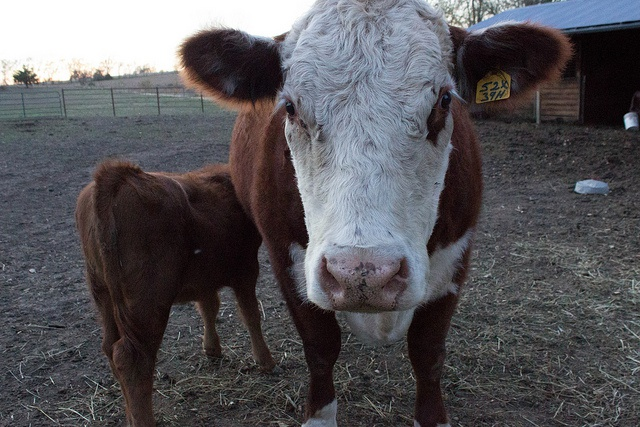Describe the objects in this image and their specific colors. I can see cow in white, black, darkgray, and gray tones and cow in white, black, gray, and maroon tones in this image. 